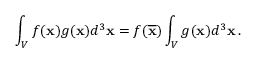Convert formula to latex. <formula><loc_0><loc_0><loc_500><loc_500>\int _ { V } f ( { x } ) g ( { x } ) d ^ { 3 } { x } = f ( \overline { x } ) \int _ { V } g ( { x } ) d ^ { 3 } { x } \, .</formula> 